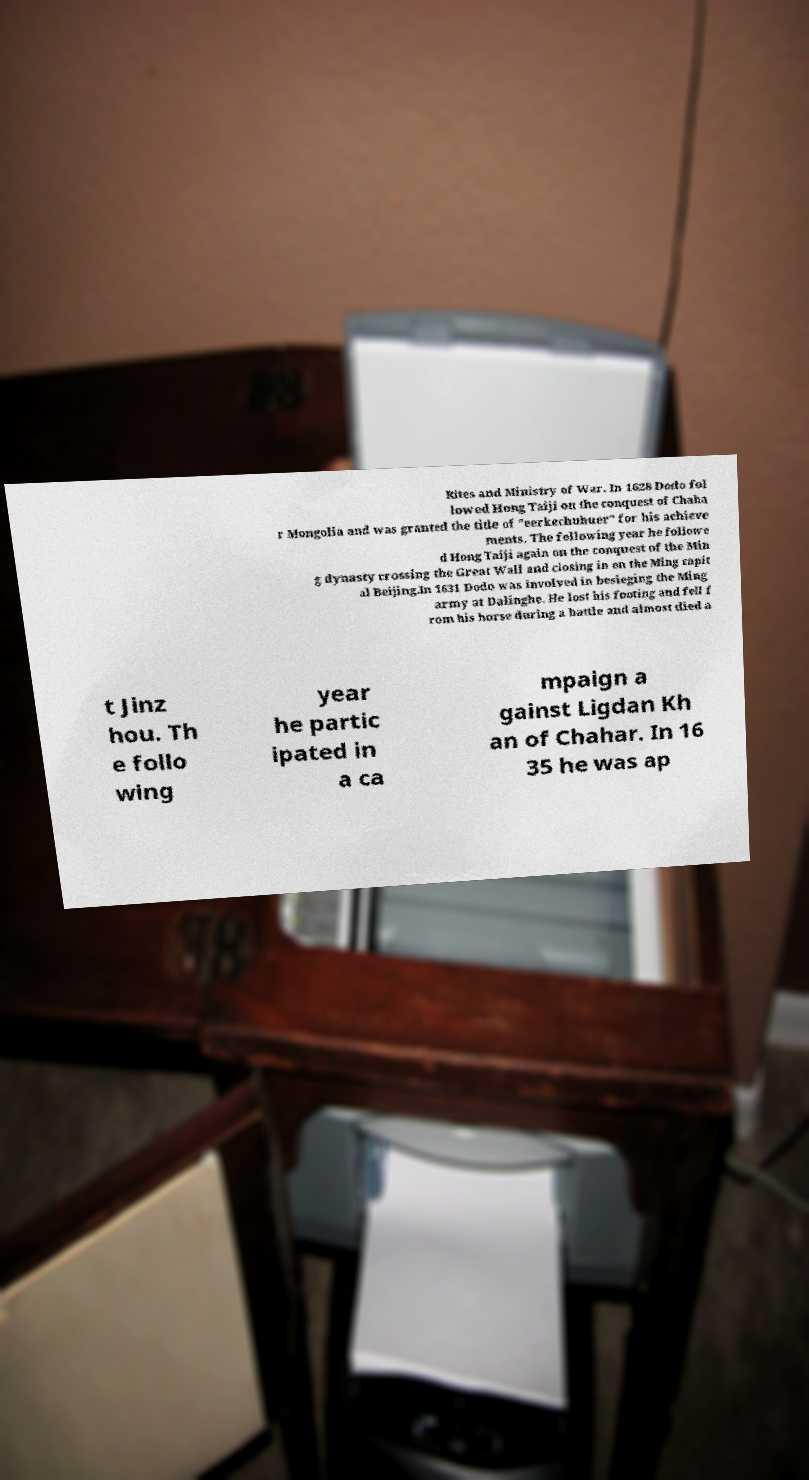Could you extract and type out the text from this image? Rites and Ministry of War. In 1628 Dodo fol lowed Hong Taiji on the conquest of Chaha r Mongolia and was granted the title of "eerkechuhuer" for his achieve ments. The following year he followe d Hong Taiji again on the conquest of the Min g dynasty crossing the Great Wall and closing in on the Ming capit al Beijing.In 1631 Dodo was involved in besieging the Ming army at Dalinghe. He lost his footing and fell f rom his horse during a battle and almost died a t Jinz hou. Th e follo wing year he partic ipated in a ca mpaign a gainst Ligdan Kh an of Chahar. In 16 35 he was ap 